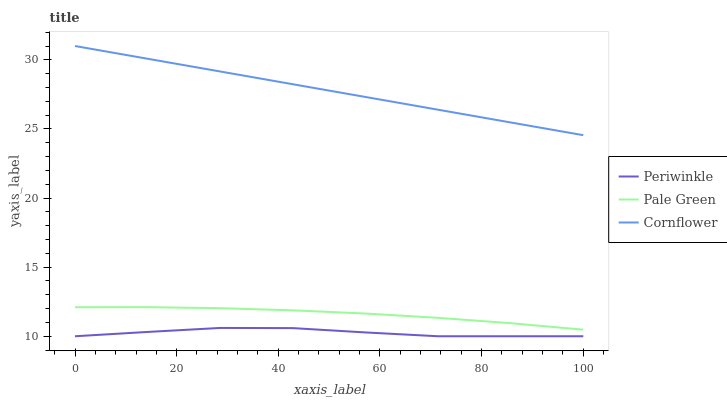Does Periwinkle have the minimum area under the curve?
Answer yes or no. Yes. Does Cornflower have the maximum area under the curve?
Answer yes or no. Yes. Does Pale Green have the minimum area under the curve?
Answer yes or no. No. Does Pale Green have the maximum area under the curve?
Answer yes or no. No. Is Cornflower the smoothest?
Answer yes or no. Yes. Is Periwinkle the roughest?
Answer yes or no. Yes. Is Pale Green the smoothest?
Answer yes or no. No. Is Pale Green the roughest?
Answer yes or no. No. Does Periwinkle have the lowest value?
Answer yes or no. Yes. Does Pale Green have the lowest value?
Answer yes or no. No. Does Cornflower have the highest value?
Answer yes or no. Yes. Does Pale Green have the highest value?
Answer yes or no. No. Is Periwinkle less than Cornflower?
Answer yes or no. Yes. Is Cornflower greater than Pale Green?
Answer yes or no. Yes. Does Periwinkle intersect Cornflower?
Answer yes or no. No. 